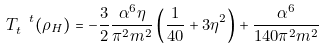<formula> <loc_0><loc_0><loc_500><loc_500>T _ { t } ^ { \ t } ( \rho _ { H } ) = - \frac { 3 } { 2 } \frac { \alpha ^ { 6 } \eta } { \pi ^ { 2 } m ^ { 2 } } \left ( \frac { 1 } { 4 0 } + 3 \eta ^ { 2 } \right ) + \frac { \alpha ^ { 6 } } { 1 4 0 \pi ^ { 2 } m ^ { 2 } }</formula> 